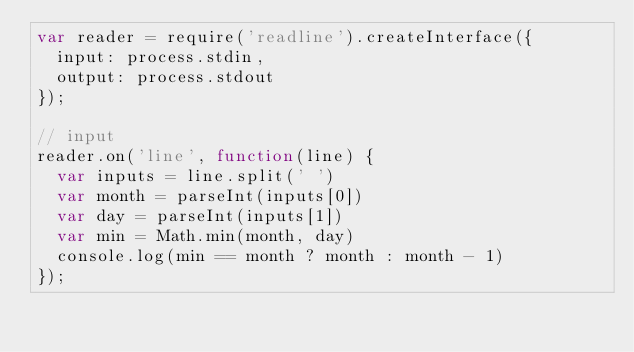Convert code to text. <code><loc_0><loc_0><loc_500><loc_500><_JavaScript_>var reader = require('readline').createInterface({
  input: process.stdin,
  output: process.stdout
});

// input
reader.on('line', function(line) {
  var inputs = line.split(' ')
  var month = parseInt(inputs[0])
  var day = parseInt(inputs[1])
  var min = Math.min(month, day)
  console.log(min == month ? month : month - 1)
});</code> 